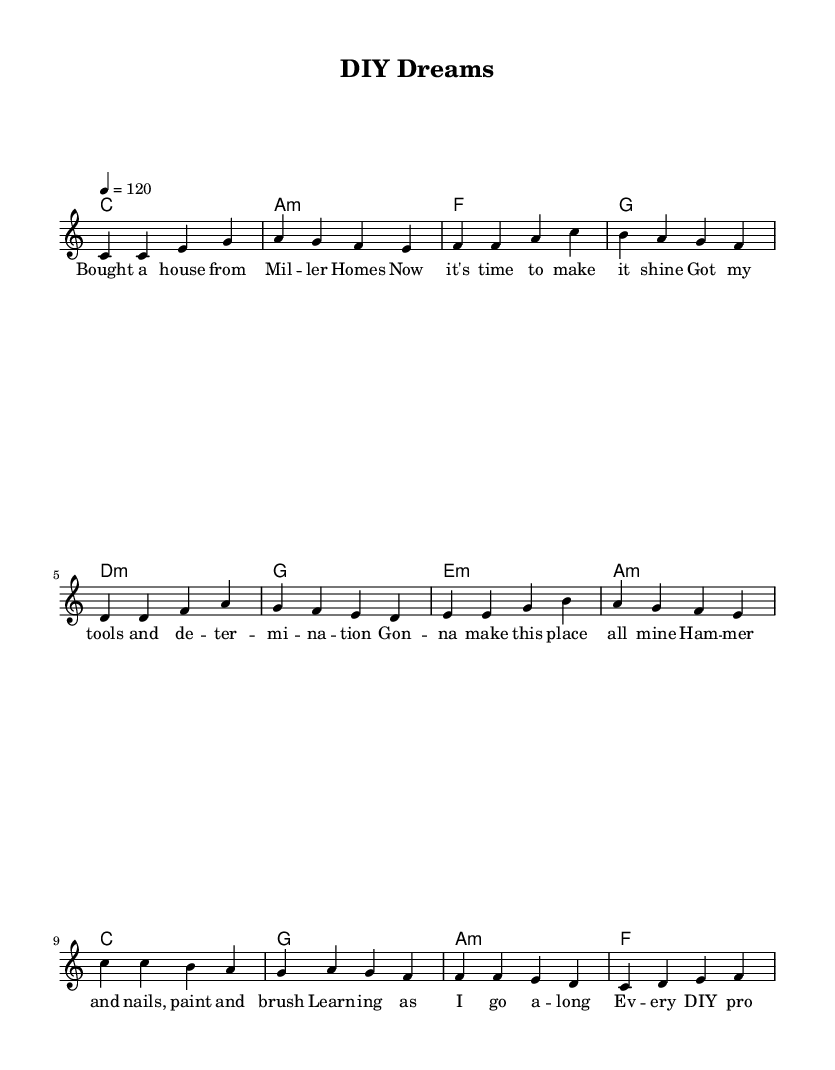What is the key signature of this music? The key signature is C major, which has no sharps or flats.
Answer: C major What is the time signature? The time signature is indicated at the beginning of the sheet music, showing that there are four beats per measure.
Answer: 4/4 What is the tempo marking? The tempo marking is shown at the beginning, which indicates the speed at which the music should be played.
Answer: 120 How many sections does the song have? The song consists of three main sections: verse, pre-chorus, and chorus. Each section has distinct lyrics and melodies.
Answer: Three What is the last chord of the chorus? To determine the last chord, we look at the harmonic progression in the chorus section of the sheet music. The final chord played is identified at the end of the chorus.
Answer: F What emotions do the lyrics convey about home improvement? The lyrics reflect feelings of determination and empowerment as the songwriter describes the DIY projects, highlighting a positive transformation of their living space.
Answer: Empowerment What musical elements are characteristic of pop in this piece? The piece features catchy melodies, repetitive lyrical themes focused on personal experience, and an uplifting rhythm, which are all common elements in pop music style.
Answer: Catchy melodies 